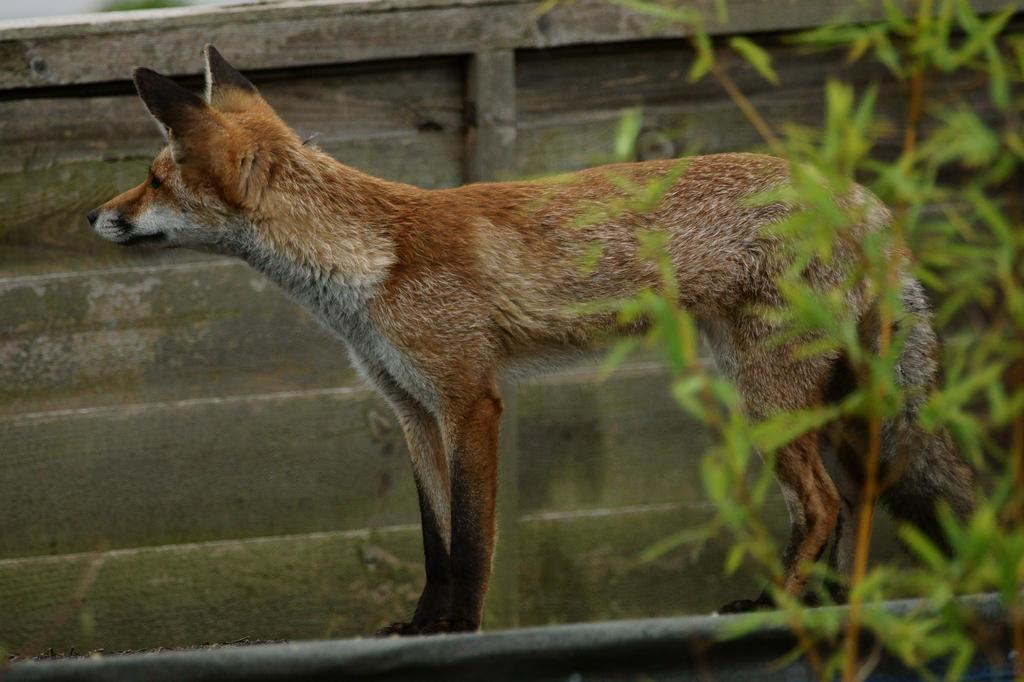What type of creature is in the image? There is an animal in the image. Can you describe the color pattern of the animal? The animal has brown and cream colors. What is the animal doing in the image? The animal is standing on some surface. What other living organism can be seen in the image? There is a plant in the image. What is the color of the plant? The plant has a green color. What type of sidewalk can be seen in the image? There is no sidewalk present in the image. 